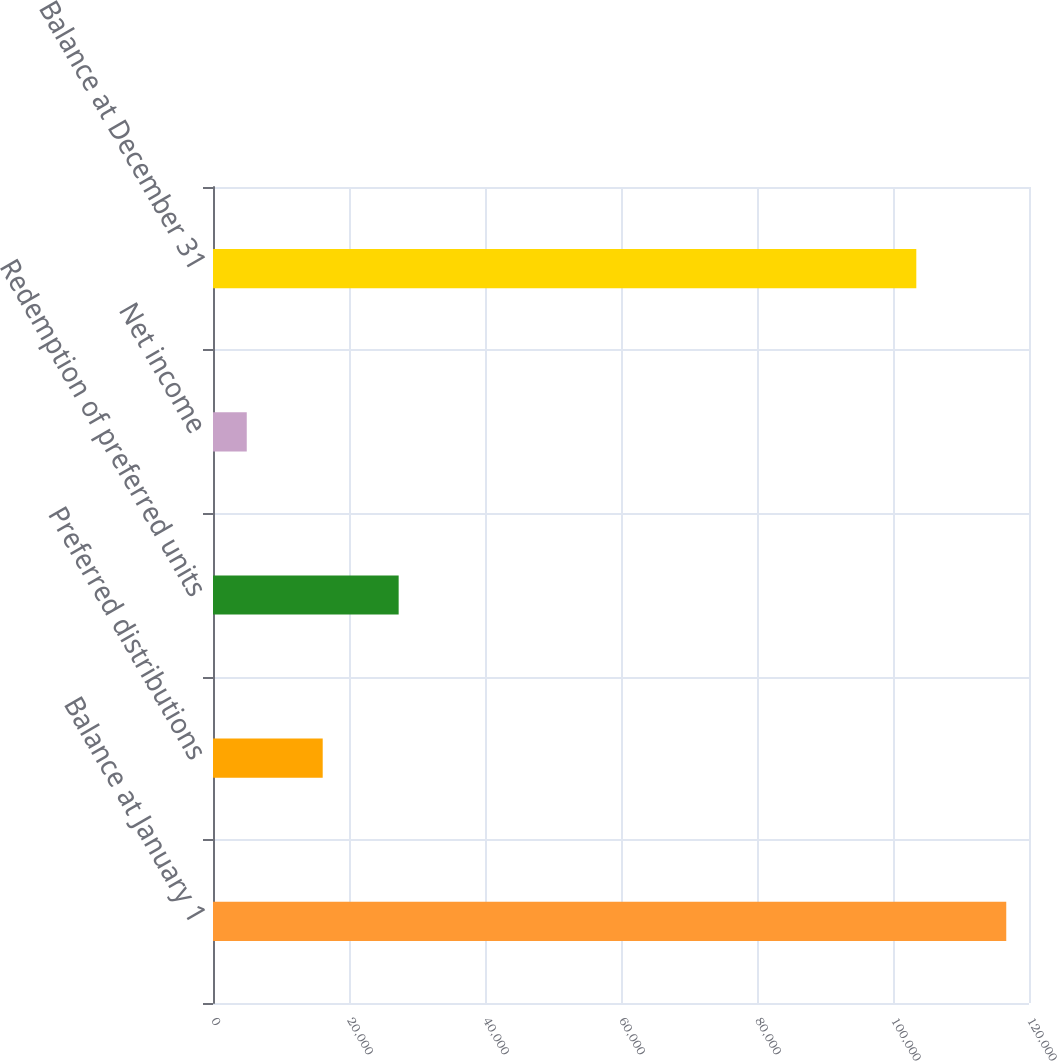Convert chart. <chart><loc_0><loc_0><loc_500><loc_500><bar_chart><fcel>Balance at January 1<fcel>Preferred distributions<fcel>Redemption of preferred units<fcel>Net income<fcel>Balance at December 31<nl><fcel>116656<fcel>16133.2<fcel>27302.4<fcel>4964<fcel>103428<nl></chart> 